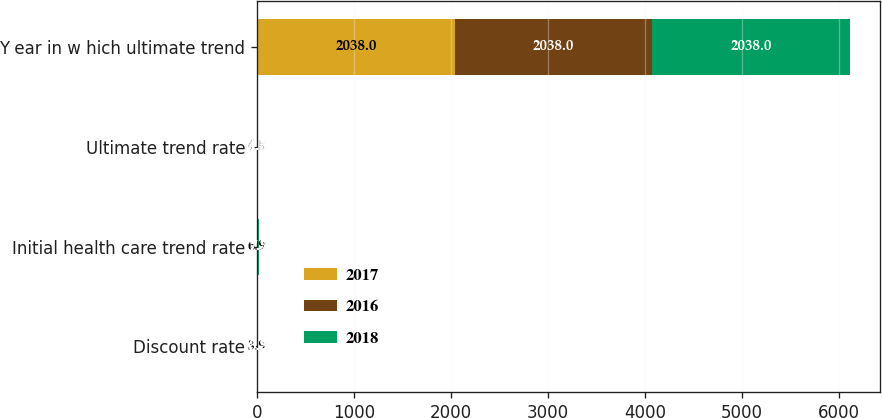<chart> <loc_0><loc_0><loc_500><loc_500><stacked_bar_chart><ecel><fcel>Discount rate<fcel>Initial health care trend rate<fcel>Ultimate trend rate<fcel>Y ear in w hich ultimate trend<nl><fcel>2017<fcel>3.9<fcel>6.9<fcel>4.5<fcel>2038<nl><fcel>2016<fcel>3.2<fcel>7.3<fcel>4.5<fcel>2038<nl><fcel>2018<fcel>3.5<fcel>7.7<fcel>4.5<fcel>2038<nl></chart> 